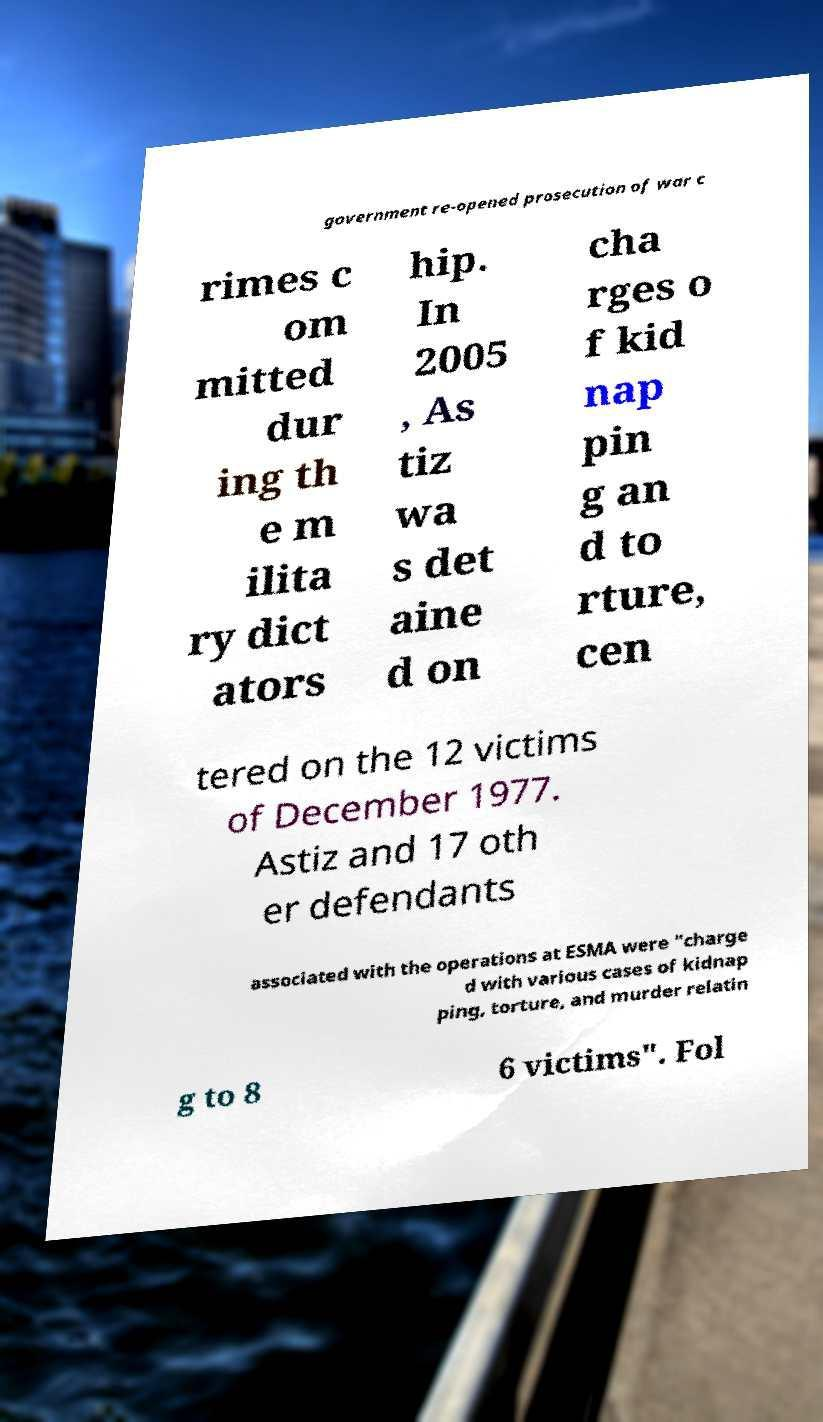Please identify and transcribe the text found in this image. government re-opened prosecution of war c rimes c om mitted dur ing th e m ilita ry dict ators hip. In 2005 , As tiz wa s det aine d on cha rges o f kid nap pin g an d to rture, cen tered on the 12 victims of December 1977. Astiz and 17 oth er defendants associated with the operations at ESMA were "charge d with various cases of kidnap ping, torture, and murder relatin g to 8 6 victims". Fol 